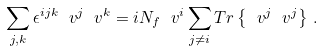<formula> <loc_0><loc_0><loc_500><loc_500>\sum _ { j , k } \epsilon ^ { i j k } \ v ^ { j } \ v ^ { k } = i N _ { f } \ v ^ { i } \sum _ { j \not = i } T r \left \{ \ v ^ { j } \ v ^ { j } \right \} \, .</formula> 